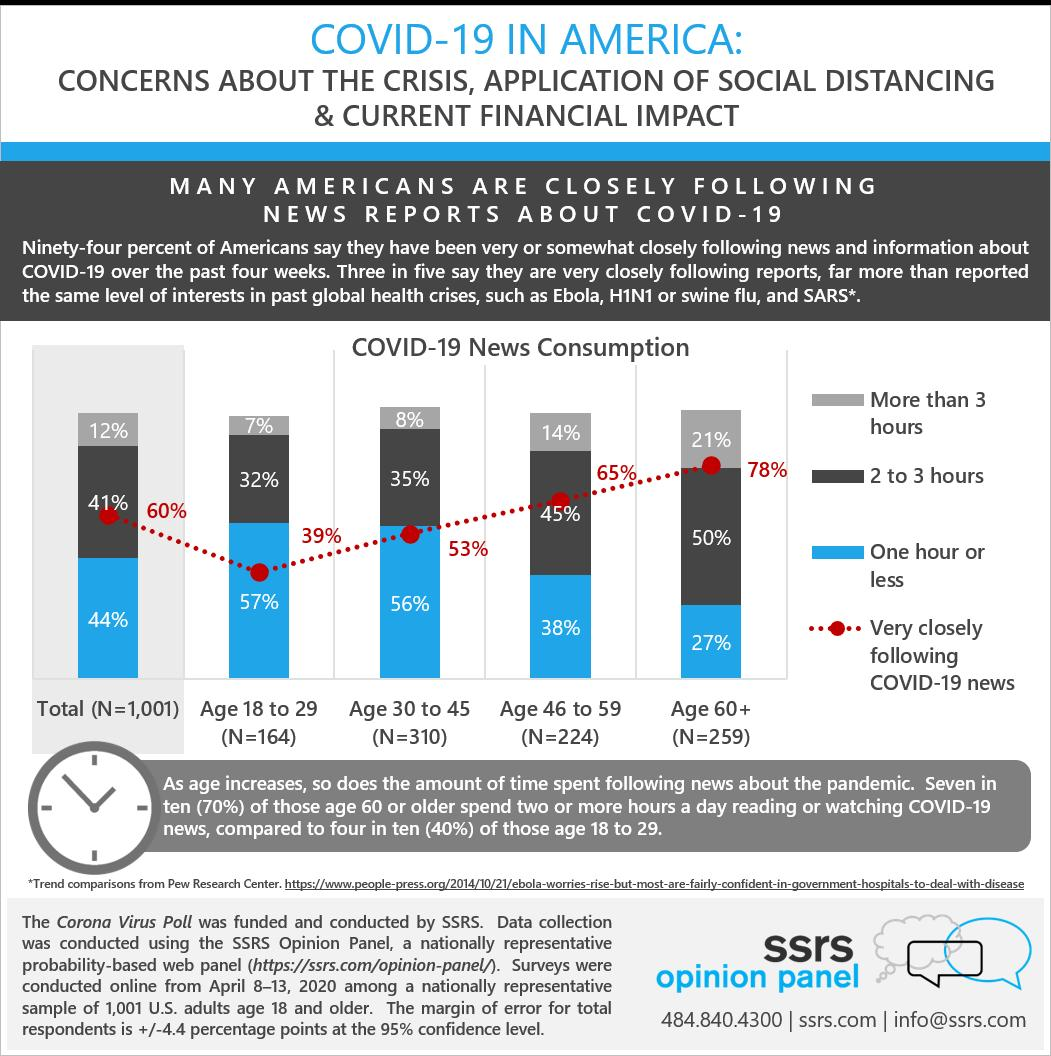Outline some significant characteristics in this image. Three viral diseases that have received significant attention in recent news reports, aside from COVID-19, are Ebola, H1N1, or swine flu, and SARS. The age group with the highest number of respondents is 30 to 45 years old. The age group with the least number of respondents is 18 to 29-year-olds. The respondents are grouped into four age groups. According to the survey, 60% of the total number of people surveyed follow the COVID-19 news very closely. 